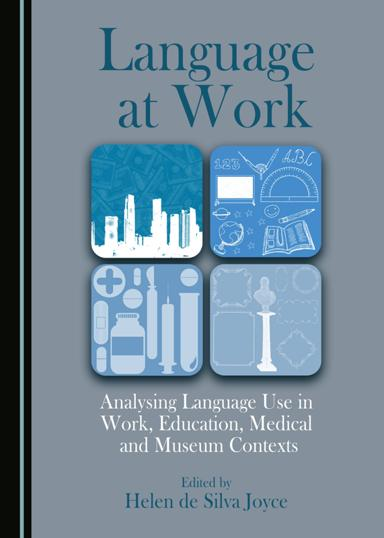What is the title of the book mentioned in the image? The title of the book is "Language at Work: Analysing Language Use in Work, Education, Medical and Museum Contexts." Who is the editor of the book? The editor of the book is Helen de Silva Joyce. 